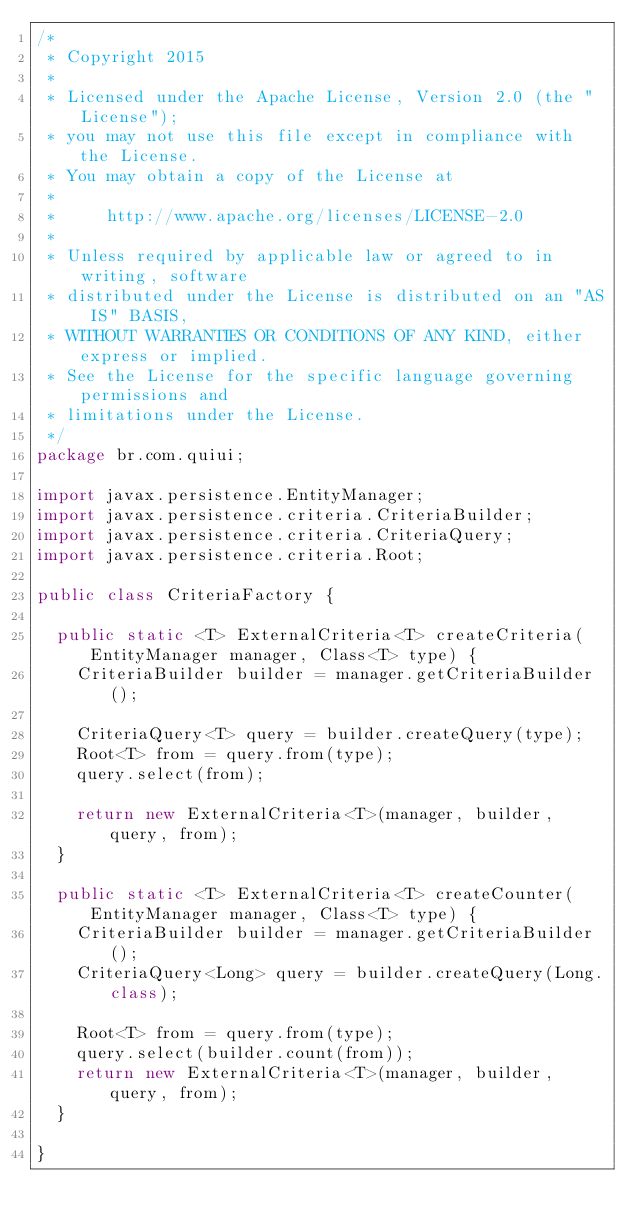<code> <loc_0><loc_0><loc_500><loc_500><_Java_>/*
 * Copyright 2015
 * 
 * Licensed under the Apache License, Version 2.0 (the "License");
 * you may not use this file except in compliance with the License.
 * You may obtain a copy of the License at
 * 
 *     http://www.apache.org/licenses/LICENSE-2.0
 * 
 * Unless required by applicable law or agreed to in writing, software
 * distributed under the License is distributed on an "AS IS" BASIS,
 * WITHOUT WARRANTIES OR CONDITIONS OF ANY KIND, either express or implied.
 * See the License for the specific language governing permissions and
 * limitations under the License.
 */
package br.com.quiui;

import javax.persistence.EntityManager;
import javax.persistence.criteria.CriteriaBuilder;
import javax.persistence.criteria.CriteriaQuery;
import javax.persistence.criteria.Root;

public class CriteriaFactory {
	
	public static <T> ExternalCriteria<T> createCriteria(EntityManager manager, Class<T> type) {
		CriteriaBuilder builder = manager.getCriteriaBuilder();
		
		CriteriaQuery<T> query = builder.createQuery(type);
		Root<T> from = query.from(type);
		query.select(from);
		
		return new ExternalCriteria<T>(manager, builder, query, from);
	}
	
	public static <T> ExternalCriteria<T> createCounter(EntityManager manager, Class<T> type) {
		CriteriaBuilder builder = manager.getCriteriaBuilder();
		CriteriaQuery<Long> query = builder.createQuery(Long.class);

		Root<T> from = query.from(type);
		query.select(builder.count(from));
		return new ExternalCriteria<T>(manager, builder, query, from);
	}

}
</code> 